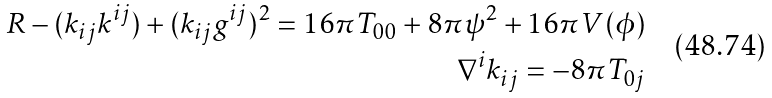<formula> <loc_0><loc_0><loc_500><loc_500>R - ( k _ { i j } k ^ { i j } ) + ( k _ { i j } g ^ { i j } ) ^ { 2 } = 1 6 \pi T _ { 0 0 } + 8 \pi \psi ^ { 2 } + 1 6 \pi V ( \phi ) \\ \nabla ^ { i } k _ { i j } = - 8 \pi T _ { 0 j }</formula> 